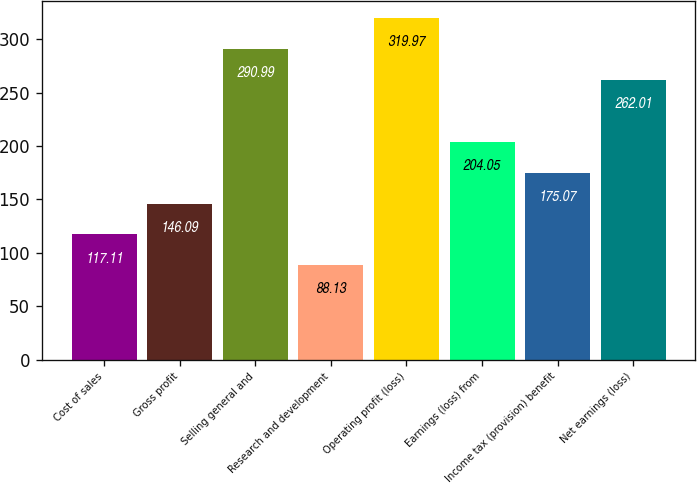<chart> <loc_0><loc_0><loc_500><loc_500><bar_chart><fcel>Cost of sales<fcel>Gross profit<fcel>Selling general and<fcel>Research and development<fcel>Operating profit (loss)<fcel>Earnings (loss) from<fcel>Income tax (provision) benefit<fcel>Net earnings (loss)<nl><fcel>117.11<fcel>146.09<fcel>290.99<fcel>88.13<fcel>319.97<fcel>204.05<fcel>175.07<fcel>262.01<nl></chart> 